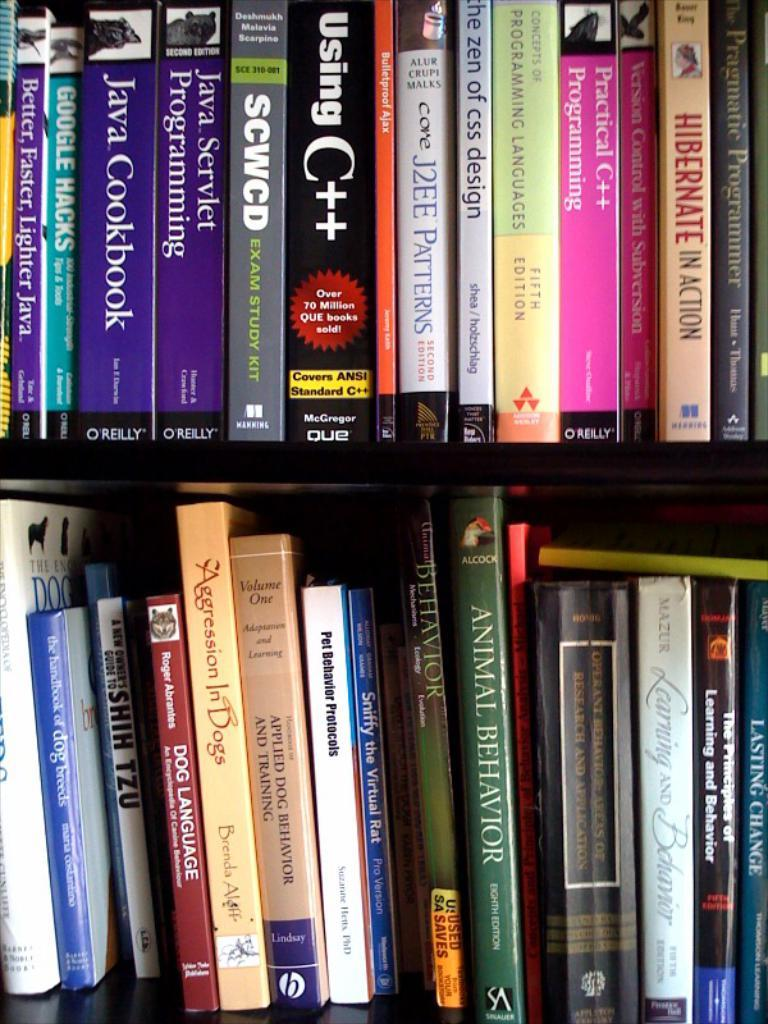<image>
Render a clear and concise summary of the photo. The title of the green book on the bottom self is called "Animal Behavior." 